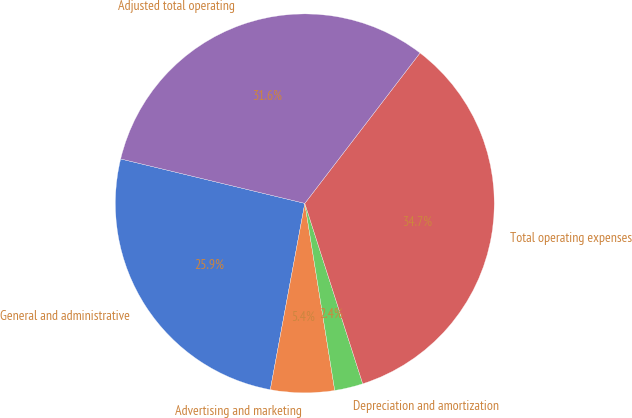Convert chart. <chart><loc_0><loc_0><loc_500><loc_500><pie_chart><fcel>General and administrative<fcel>Advertising and marketing<fcel>Depreciation and amortization<fcel>Total operating expenses<fcel>Adjusted total operating<nl><fcel>25.85%<fcel>5.44%<fcel>2.42%<fcel>34.65%<fcel>31.63%<nl></chart> 